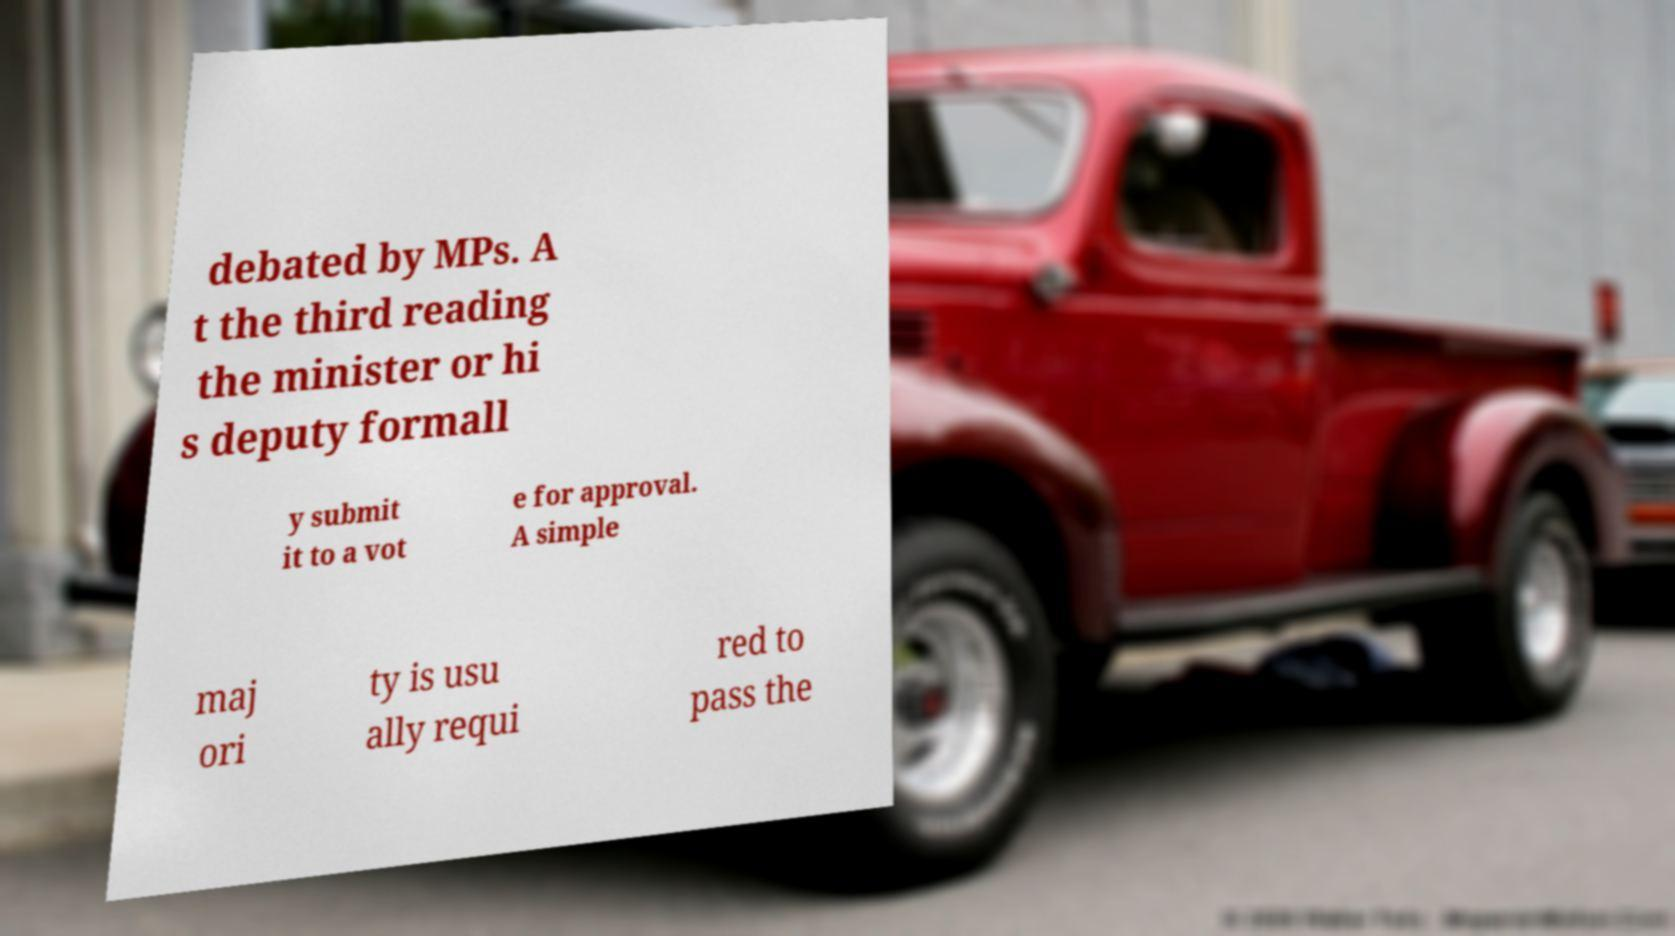Can you accurately transcribe the text from the provided image for me? debated by MPs. A t the third reading the minister or hi s deputy formall y submit it to a vot e for approval. A simple maj ori ty is usu ally requi red to pass the 